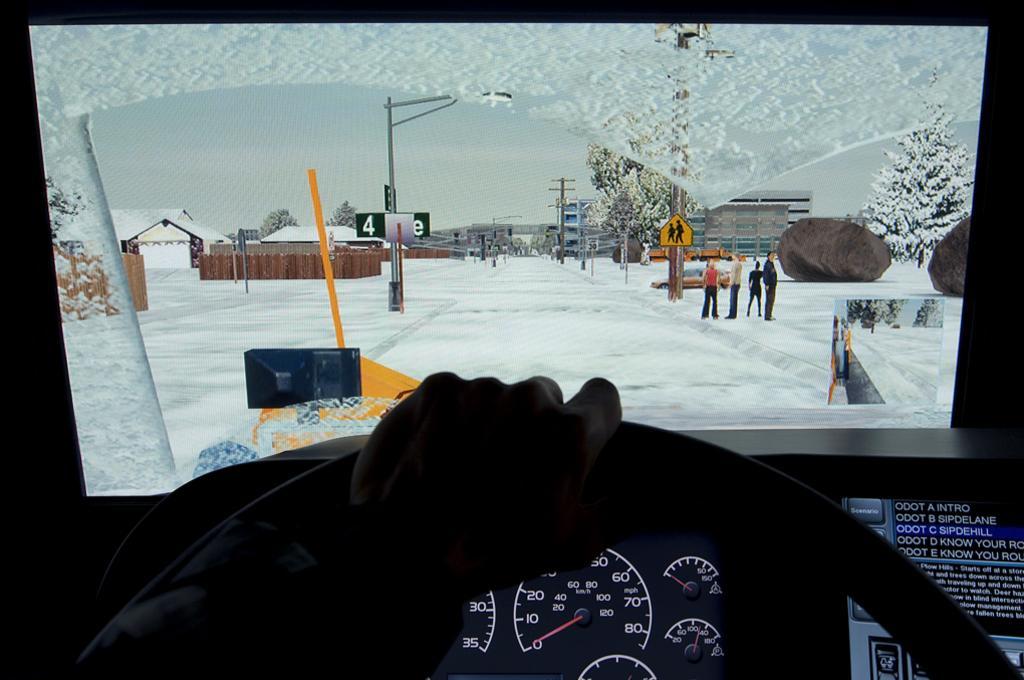How would you summarize this image in a sentence or two? In this image I can see a human hand on the steering. Background I can see group of people standing, few vehicles covered with snow, trees in green color, few poles, and sky in white color. 